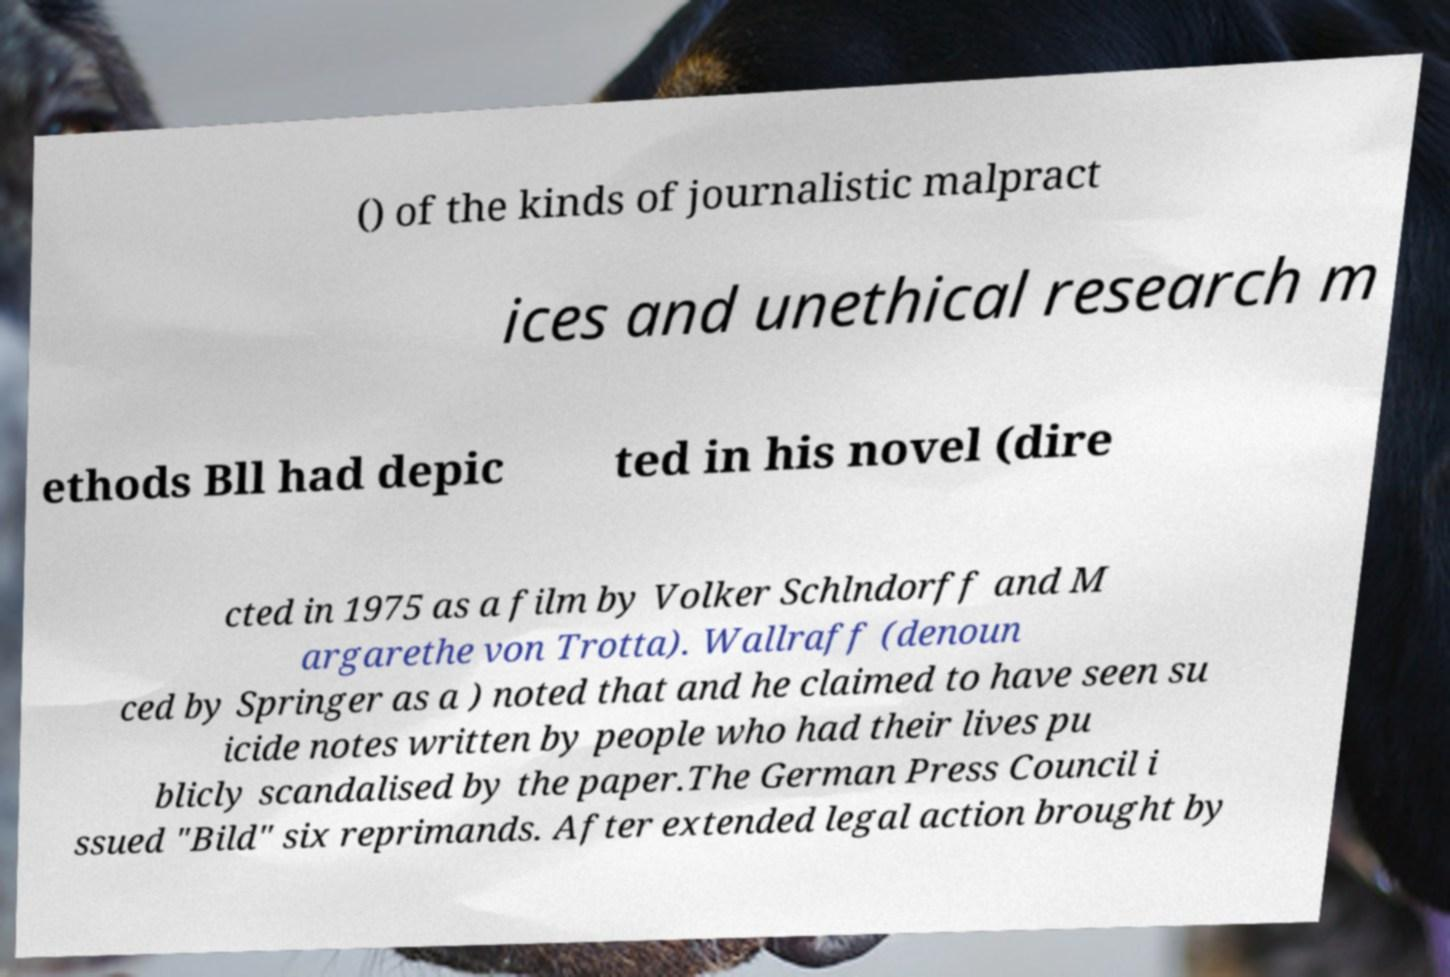Please identify and transcribe the text found in this image. () of the kinds of journalistic malpract ices and unethical research m ethods Bll had depic ted in his novel (dire cted in 1975 as a film by Volker Schlndorff and M argarethe von Trotta). Wallraff (denoun ced by Springer as a ) noted that and he claimed to have seen su icide notes written by people who had their lives pu blicly scandalised by the paper.The German Press Council i ssued "Bild" six reprimands. After extended legal action brought by 